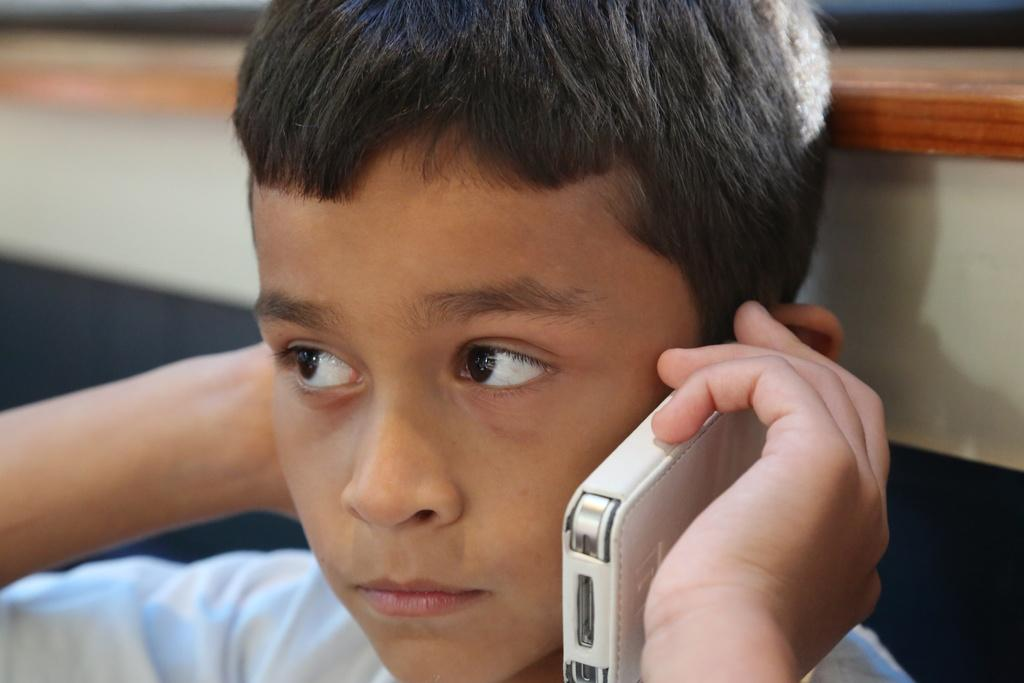What is the person in the image doing with their left hand? The person is holding a phone in their left hand. What action is the person taking with the phone? The person is answering the phone. Can you describe the background of the image? There is a brown and white color wall in the background of the image. What type of skirt is the person wearing in the image? There is no skirt visible in the image; the person is wearing a phone in their left hand. 